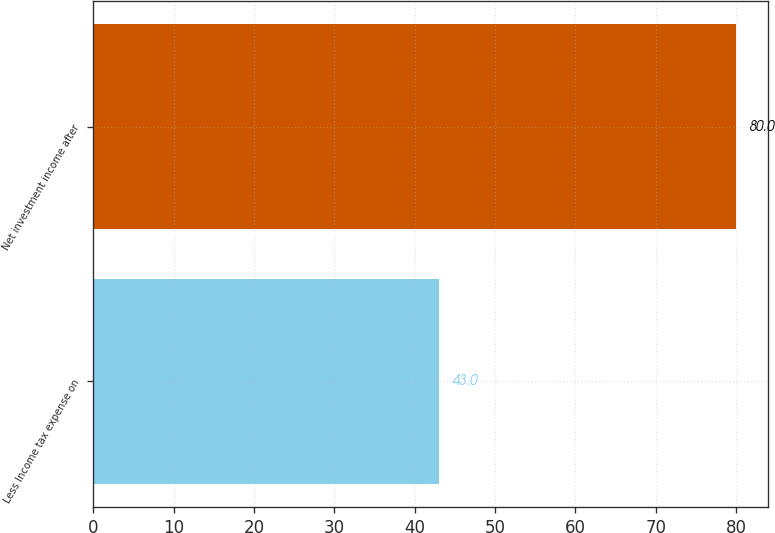<chart> <loc_0><loc_0><loc_500><loc_500><bar_chart><fcel>Less Income tax expense on<fcel>Net investment income after<nl><fcel>43<fcel>80<nl></chart> 